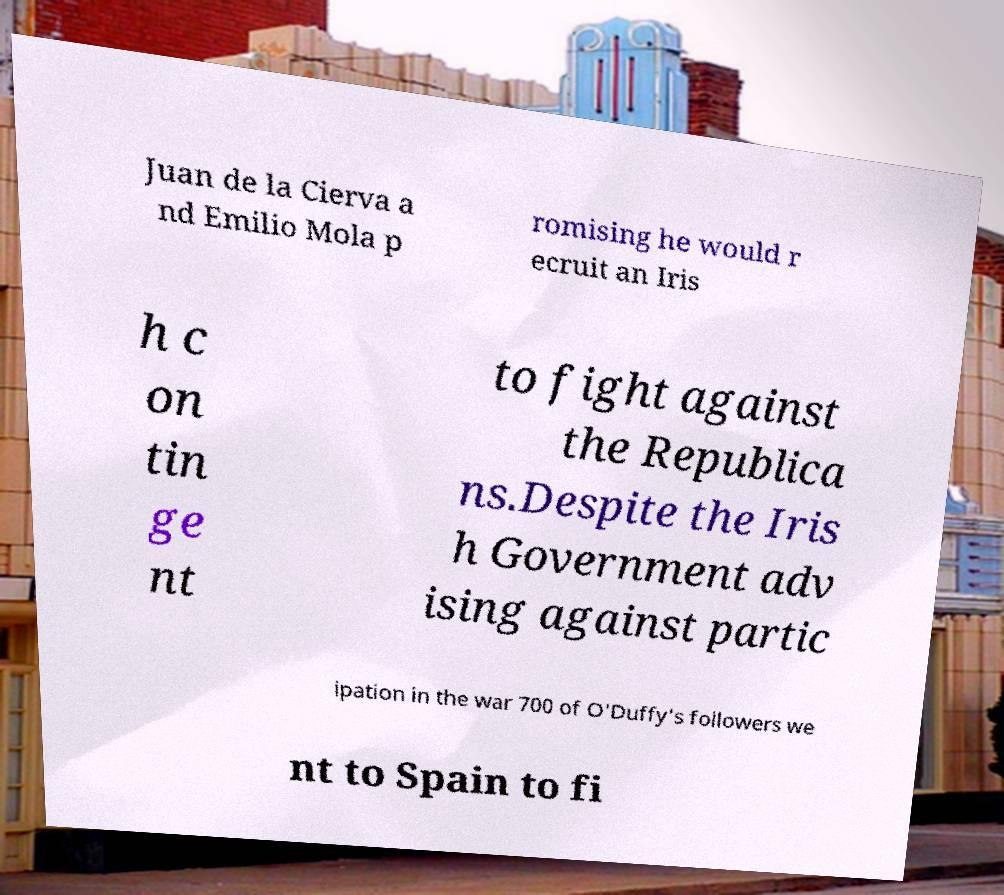For documentation purposes, I need the text within this image transcribed. Could you provide that? Juan de la Cierva a nd Emilio Mola p romising he would r ecruit an Iris h c on tin ge nt to fight against the Republica ns.Despite the Iris h Government adv ising against partic ipation in the war 700 of O'Duffy's followers we nt to Spain to fi 